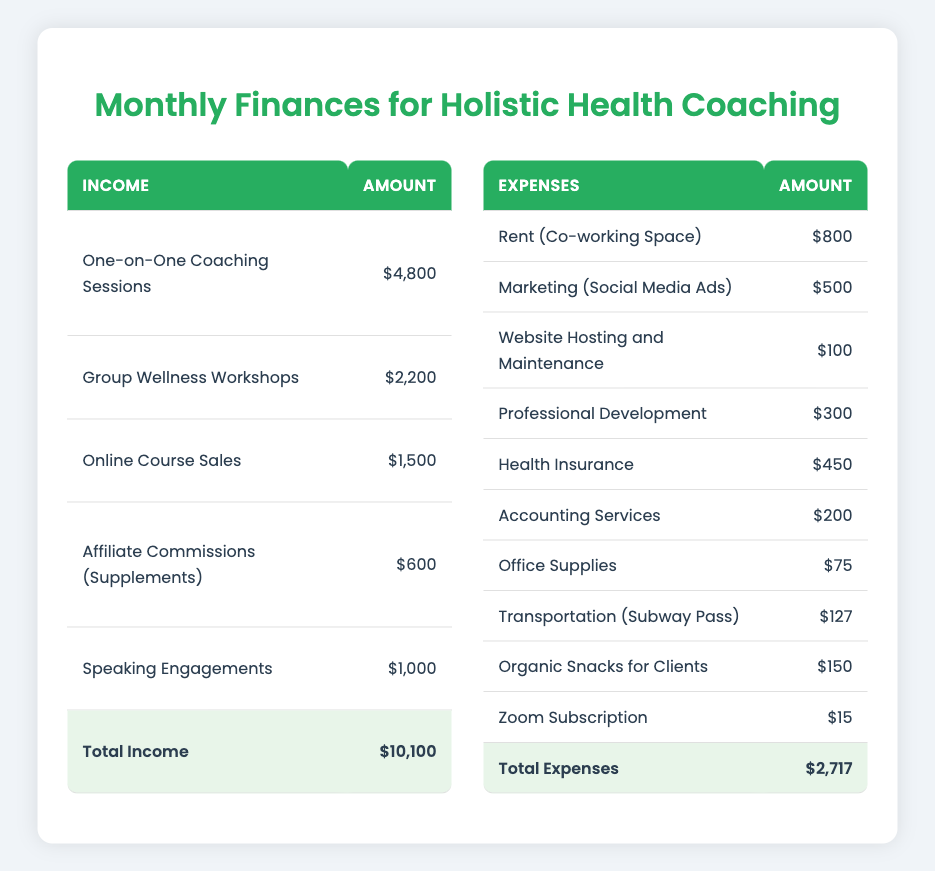What is the total monthly income for the holistic health coaching business? The total monthly income can be found in the last row of the income table, which sums up all individual income categories. The sum is $4,800 + $2,200 + $1,500 + $600 + $1,000 = $10,100.
Answer: 10,100 Which category of income has the highest amount? By reviewing the individual amounts listed under the income categories, we see that "One-on-One Coaching Sessions" has the highest amount at $4,800.
Answer: One-on-One Coaching Sessions What are the total monthly expenses for the coaching business? The total monthly expenses are provided in the last row of the expenses table. Summing all the expense categories results in $800 + $500 + $100 + $300 + $450 + $200 + $75 + $127 + $150 + $15 = $2,717.
Answer: 2,717 Is the total income greater than the total expenses? To determine this, we compare the total income ($10,100) with the total expenses ($2,717). Since $10,100 is greater than $2,717, the statement is true.
Answer: Yes What percentage of total income comes from "Group Wellness Workshops"? First, identify the amount from "Group Wellness Workshops," which is $2,200. To find the percentage, use the formula (individual amount / total income) * 100. This results in ($2,200 / $10,100) * 100 = approximately 21.78%.
Answer: 21.78% What is the difference in amount between the highest and lowest expense categories? The highest expense category is "Rent (Co-working Space)" at $800, and the lowest is "Zoom Subscription" at $15. To find the difference, subtract the lower amount from the higher amount: $800 - $15 = $785.
Answer: 785 Are more resources spent on marketing or professional development? Compare the amounts: Marketing (Social Media Ads) is $500 and Professional Development (Workshops, Books) is $300. Since $500 is greater than $300, more resources are spent on marketing.
Answer: Marketing If the income from "Online Course Sales" were to increase by 20%, what would the new total income be? The current amount for "Online Course Sales" is $1,500. An increase of 20% would be calculated as $1,500 * 0.20 = $300. The new total for "Online Course Sales" would then be $1,500 + $300 = $1,800. Adding this to the total income ($10,100 - $1,500 + $1,800) gives $10,400.
Answer: 10,400 What is the total amount spent on office-related expenses (including rent and office supplies)? The relevant expense categories are Rent ($800) and Office Supplies ($75). The sum of these amounts is $800 + $75 = $875.
Answer: 875 